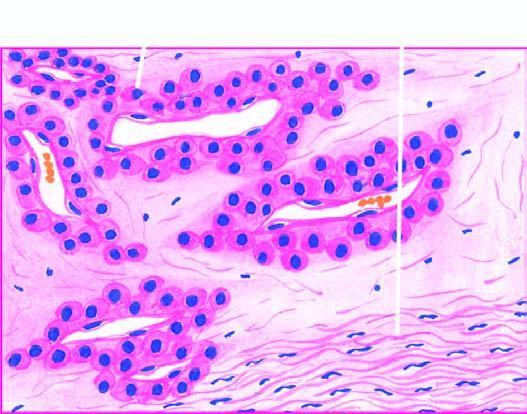re disse blood-filled vascular channels lined by endothelial cells and surrounded by nests and masses of glomus cells?
Answer the question using a single word or phrase. No 